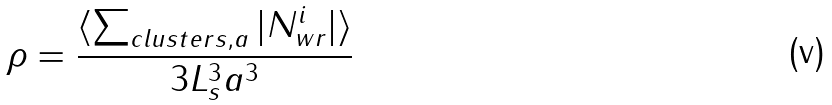Convert formula to latex. <formula><loc_0><loc_0><loc_500><loc_500>\rho = \frac { \langle \sum _ { c l u s t e r s , a } | N ^ { i } _ { w r } | \rangle } { 3 L _ { s } ^ { 3 } a ^ { 3 } }</formula> 